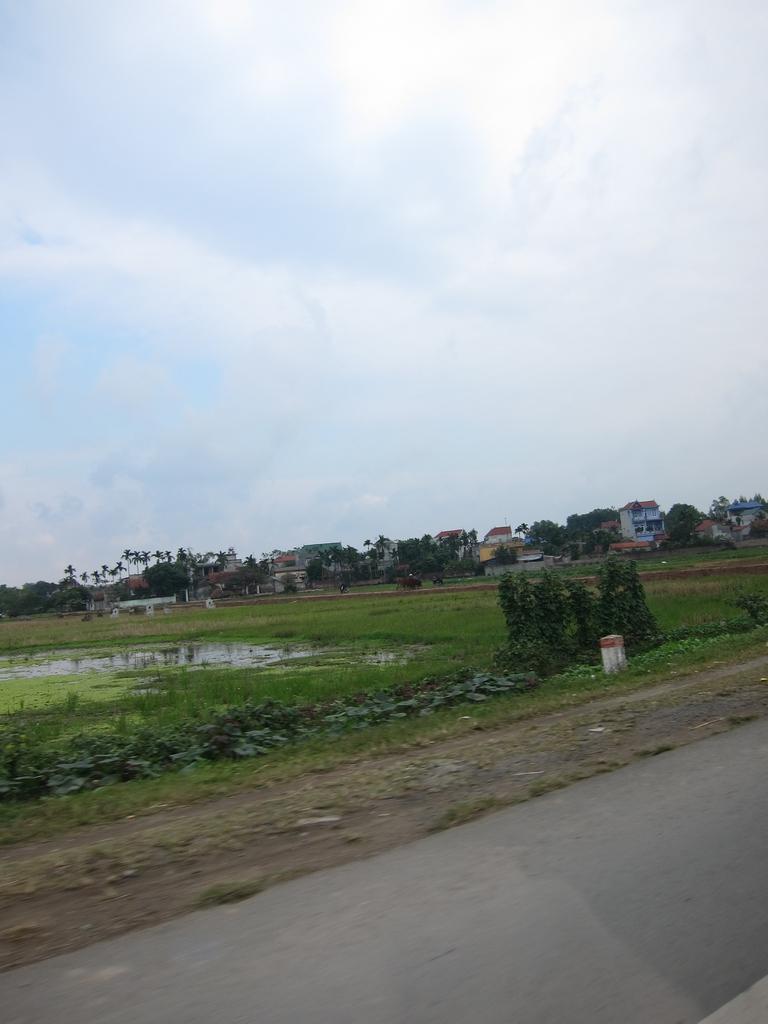Could you give a brief overview of what you see in this image? In this picture we can see plants, water, trees and houses. Behind the houses there is the sky. In front of the plants there is a road. 